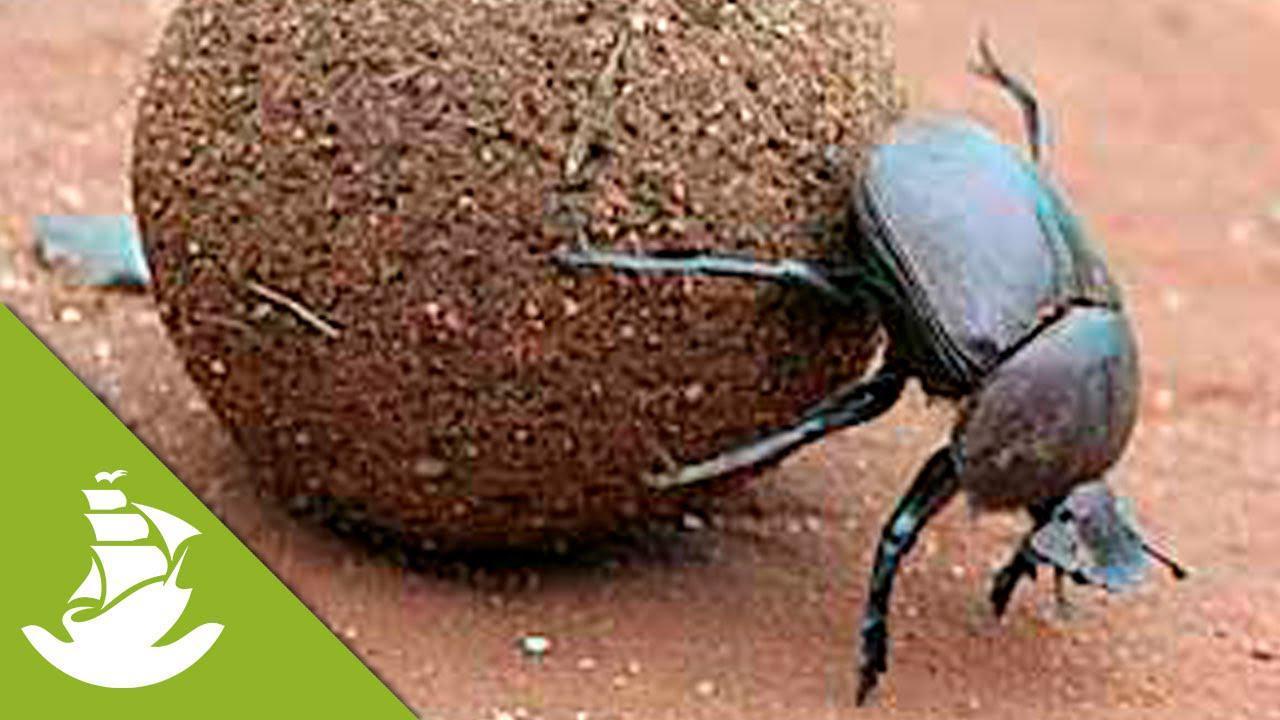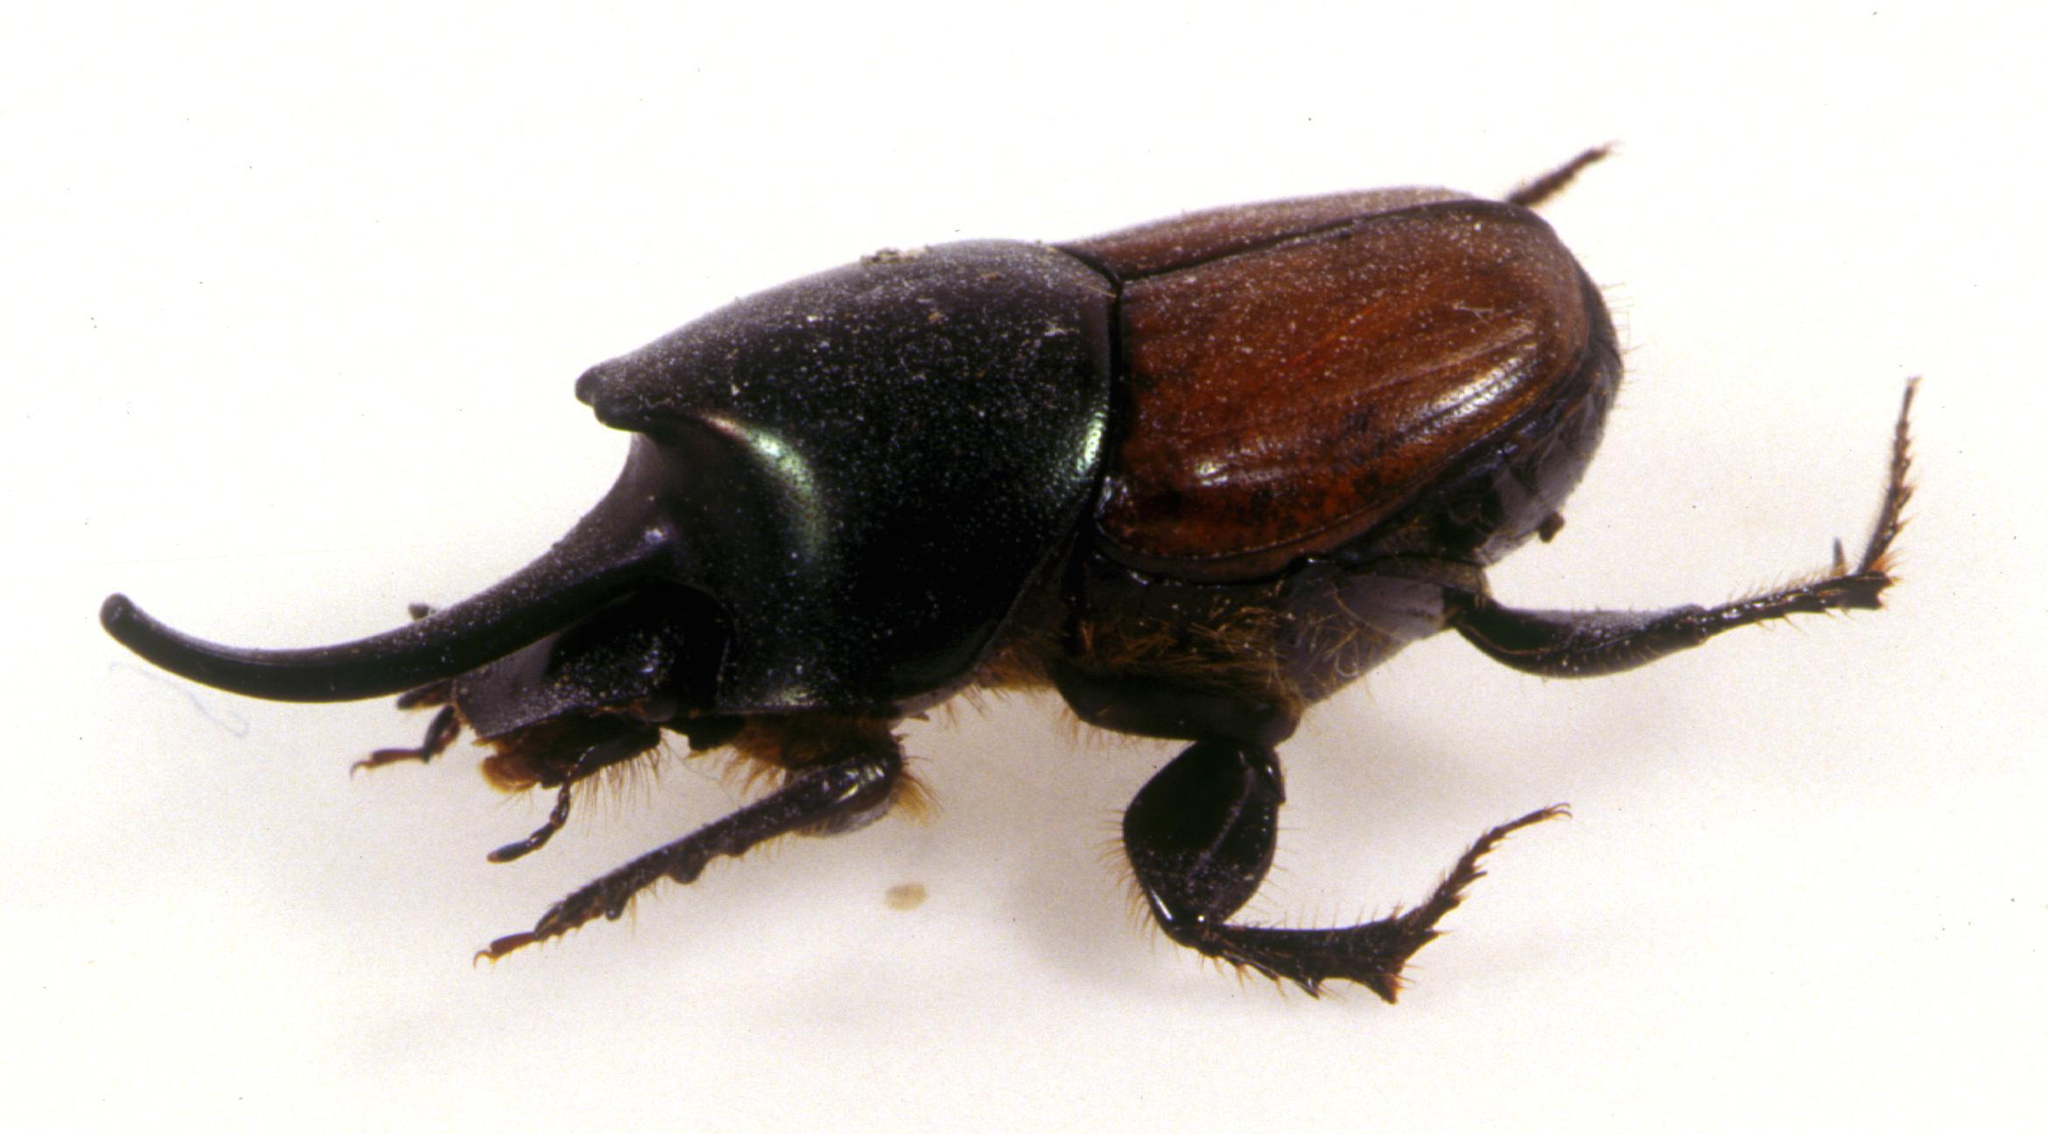The first image is the image on the left, the second image is the image on the right. Assess this claim about the two images: "In one of the image a dung beetle is on top of the dung ball.". Correct or not? Answer yes or no. No. The first image is the image on the left, the second image is the image on the right. Analyze the images presented: Is the assertion "One dung beetle does not have a single limb touching the ground." valid? Answer yes or no. No. 